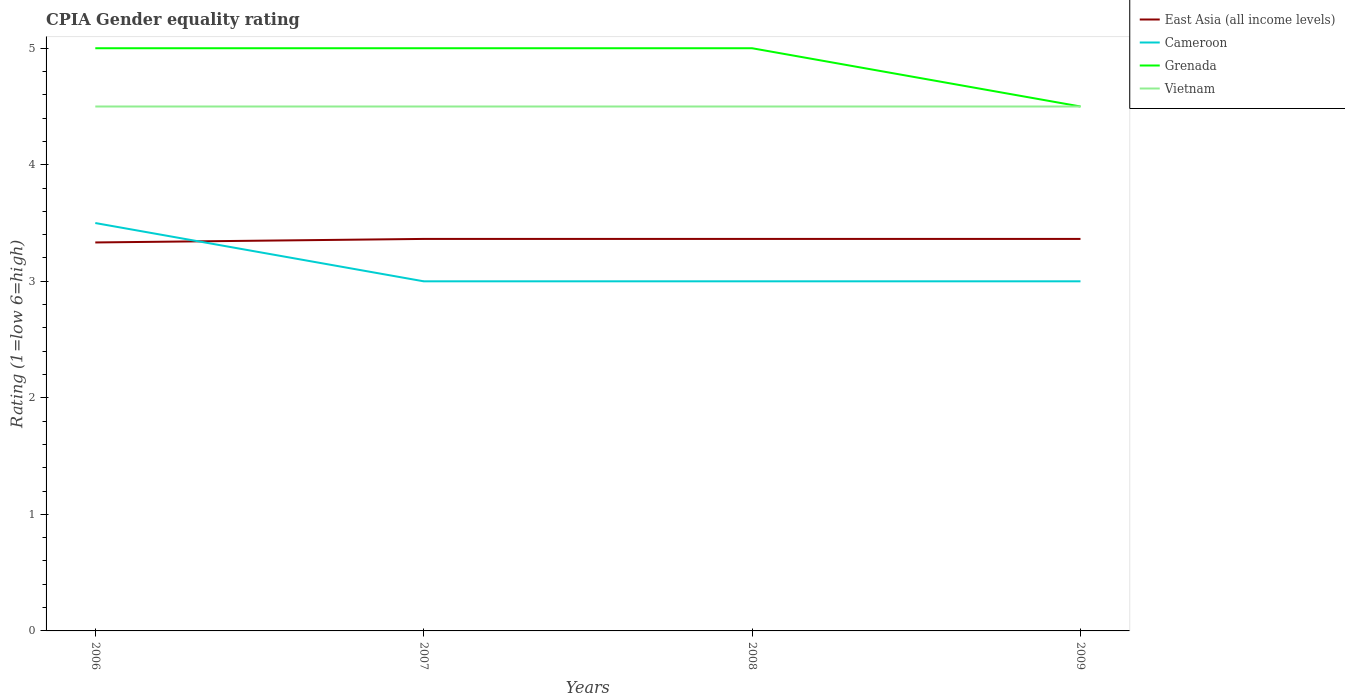In which year was the CPIA rating in Grenada maximum?
Provide a succinct answer. 2009. What is the total CPIA rating in Cameroon in the graph?
Keep it short and to the point. 0.5. What is the difference between the highest and the second highest CPIA rating in Cameroon?
Your answer should be compact. 0.5. How many lines are there?
Provide a short and direct response. 4. How many years are there in the graph?
Offer a very short reply. 4. How many legend labels are there?
Your answer should be compact. 4. What is the title of the graph?
Give a very brief answer. CPIA Gender equality rating. Does "East Asia (developing only)" appear as one of the legend labels in the graph?
Provide a succinct answer. No. What is the label or title of the X-axis?
Ensure brevity in your answer.  Years. What is the Rating (1=low 6=high) in East Asia (all income levels) in 2006?
Provide a succinct answer. 3.33. What is the Rating (1=low 6=high) in East Asia (all income levels) in 2007?
Keep it short and to the point. 3.36. What is the Rating (1=low 6=high) of Grenada in 2007?
Your response must be concise. 5. What is the Rating (1=low 6=high) in East Asia (all income levels) in 2008?
Make the answer very short. 3.36. What is the Rating (1=low 6=high) in Grenada in 2008?
Offer a terse response. 5. What is the Rating (1=low 6=high) in Vietnam in 2008?
Provide a succinct answer. 4.5. What is the Rating (1=low 6=high) in East Asia (all income levels) in 2009?
Your answer should be very brief. 3.36. What is the Rating (1=low 6=high) in Grenada in 2009?
Keep it short and to the point. 4.5. What is the Rating (1=low 6=high) of Vietnam in 2009?
Provide a succinct answer. 4.5. Across all years, what is the maximum Rating (1=low 6=high) of East Asia (all income levels)?
Your response must be concise. 3.36. Across all years, what is the maximum Rating (1=low 6=high) in Cameroon?
Give a very brief answer. 3.5. Across all years, what is the maximum Rating (1=low 6=high) of Grenada?
Your answer should be very brief. 5. Across all years, what is the maximum Rating (1=low 6=high) of Vietnam?
Your answer should be compact. 4.5. Across all years, what is the minimum Rating (1=low 6=high) of East Asia (all income levels)?
Make the answer very short. 3.33. What is the total Rating (1=low 6=high) in East Asia (all income levels) in the graph?
Your answer should be very brief. 13.42. What is the total Rating (1=low 6=high) of Vietnam in the graph?
Give a very brief answer. 18. What is the difference between the Rating (1=low 6=high) of East Asia (all income levels) in 2006 and that in 2007?
Your response must be concise. -0.03. What is the difference between the Rating (1=low 6=high) in Cameroon in 2006 and that in 2007?
Offer a terse response. 0.5. What is the difference between the Rating (1=low 6=high) in Grenada in 2006 and that in 2007?
Give a very brief answer. 0. What is the difference between the Rating (1=low 6=high) in East Asia (all income levels) in 2006 and that in 2008?
Your response must be concise. -0.03. What is the difference between the Rating (1=low 6=high) in Cameroon in 2006 and that in 2008?
Provide a succinct answer. 0.5. What is the difference between the Rating (1=low 6=high) of East Asia (all income levels) in 2006 and that in 2009?
Ensure brevity in your answer.  -0.03. What is the difference between the Rating (1=low 6=high) of Cameroon in 2006 and that in 2009?
Your answer should be compact. 0.5. What is the difference between the Rating (1=low 6=high) of Vietnam in 2006 and that in 2009?
Your response must be concise. 0. What is the difference between the Rating (1=low 6=high) of East Asia (all income levels) in 2007 and that in 2008?
Provide a short and direct response. 0. What is the difference between the Rating (1=low 6=high) in Vietnam in 2007 and that in 2008?
Offer a very short reply. 0. What is the difference between the Rating (1=low 6=high) in East Asia (all income levels) in 2007 and that in 2009?
Ensure brevity in your answer.  0. What is the difference between the Rating (1=low 6=high) in Grenada in 2007 and that in 2009?
Ensure brevity in your answer.  0.5. What is the difference between the Rating (1=low 6=high) of Vietnam in 2007 and that in 2009?
Provide a short and direct response. 0. What is the difference between the Rating (1=low 6=high) of Cameroon in 2008 and that in 2009?
Your response must be concise. 0. What is the difference between the Rating (1=low 6=high) in Grenada in 2008 and that in 2009?
Ensure brevity in your answer.  0.5. What is the difference between the Rating (1=low 6=high) of East Asia (all income levels) in 2006 and the Rating (1=low 6=high) of Grenada in 2007?
Keep it short and to the point. -1.67. What is the difference between the Rating (1=low 6=high) of East Asia (all income levels) in 2006 and the Rating (1=low 6=high) of Vietnam in 2007?
Ensure brevity in your answer.  -1.17. What is the difference between the Rating (1=low 6=high) in East Asia (all income levels) in 2006 and the Rating (1=low 6=high) in Cameroon in 2008?
Your answer should be compact. 0.33. What is the difference between the Rating (1=low 6=high) of East Asia (all income levels) in 2006 and the Rating (1=low 6=high) of Grenada in 2008?
Your answer should be very brief. -1.67. What is the difference between the Rating (1=low 6=high) of East Asia (all income levels) in 2006 and the Rating (1=low 6=high) of Vietnam in 2008?
Offer a terse response. -1.17. What is the difference between the Rating (1=low 6=high) of Cameroon in 2006 and the Rating (1=low 6=high) of Vietnam in 2008?
Offer a very short reply. -1. What is the difference between the Rating (1=low 6=high) in East Asia (all income levels) in 2006 and the Rating (1=low 6=high) in Cameroon in 2009?
Keep it short and to the point. 0.33. What is the difference between the Rating (1=low 6=high) of East Asia (all income levels) in 2006 and the Rating (1=low 6=high) of Grenada in 2009?
Provide a succinct answer. -1.17. What is the difference between the Rating (1=low 6=high) in East Asia (all income levels) in 2006 and the Rating (1=low 6=high) in Vietnam in 2009?
Offer a terse response. -1.17. What is the difference between the Rating (1=low 6=high) in East Asia (all income levels) in 2007 and the Rating (1=low 6=high) in Cameroon in 2008?
Your answer should be very brief. 0.36. What is the difference between the Rating (1=low 6=high) of East Asia (all income levels) in 2007 and the Rating (1=low 6=high) of Grenada in 2008?
Provide a succinct answer. -1.64. What is the difference between the Rating (1=low 6=high) in East Asia (all income levels) in 2007 and the Rating (1=low 6=high) in Vietnam in 2008?
Your answer should be compact. -1.14. What is the difference between the Rating (1=low 6=high) in Cameroon in 2007 and the Rating (1=low 6=high) in Vietnam in 2008?
Ensure brevity in your answer.  -1.5. What is the difference between the Rating (1=low 6=high) in East Asia (all income levels) in 2007 and the Rating (1=low 6=high) in Cameroon in 2009?
Offer a terse response. 0.36. What is the difference between the Rating (1=low 6=high) in East Asia (all income levels) in 2007 and the Rating (1=low 6=high) in Grenada in 2009?
Offer a very short reply. -1.14. What is the difference between the Rating (1=low 6=high) of East Asia (all income levels) in 2007 and the Rating (1=low 6=high) of Vietnam in 2009?
Make the answer very short. -1.14. What is the difference between the Rating (1=low 6=high) in Grenada in 2007 and the Rating (1=low 6=high) in Vietnam in 2009?
Your answer should be very brief. 0.5. What is the difference between the Rating (1=low 6=high) in East Asia (all income levels) in 2008 and the Rating (1=low 6=high) in Cameroon in 2009?
Ensure brevity in your answer.  0.36. What is the difference between the Rating (1=low 6=high) of East Asia (all income levels) in 2008 and the Rating (1=low 6=high) of Grenada in 2009?
Offer a terse response. -1.14. What is the difference between the Rating (1=low 6=high) in East Asia (all income levels) in 2008 and the Rating (1=low 6=high) in Vietnam in 2009?
Ensure brevity in your answer.  -1.14. What is the difference between the Rating (1=low 6=high) of Cameroon in 2008 and the Rating (1=low 6=high) of Grenada in 2009?
Offer a very short reply. -1.5. What is the difference between the Rating (1=low 6=high) in Cameroon in 2008 and the Rating (1=low 6=high) in Vietnam in 2009?
Offer a terse response. -1.5. What is the average Rating (1=low 6=high) in East Asia (all income levels) per year?
Your answer should be compact. 3.36. What is the average Rating (1=low 6=high) in Cameroon per year?
Offer a very short reply. 3.12. What is the average Rating (1=low 6=high) of Grenada per year?
Keep it short and to the point. 4.88. What is the average Rating (1=low 6=high) of Vietnam per year?
Offer a very short reply. 4.5. In the year 2006, what is the difference between the Rating (1=low 6=high) of East Asia (all income levels) and Rating (1=low 6=high) of Grenada?
Your answer should be very brief. -1.67. In the year 2006, what is the difference between the Rating (1=low 6=high) of East Asia (all income levels) and Rating (1=low 6=high) of Vietnam?
Your answer should be very brief. -1.17. In the year 2006, what is the difference between the Rating (1=low 6=high) of Grenada and Rating (1=low 6=high) of Vietnam?
Give a very brief answer. 0.5. In the year 2007, what is the difference between the Rating (1=low 6=high) in East Asia (all income levels) and Rating (1=low 6=high) in Cameroon?
Give a very brief answer. 0.36. In the year 2007, what is the difference between the Rating (1=low 6=high) of East Asia (all income levels) and Rating (1=low 6=high) of Grenada?
Offer a very short reply. -1.64. In the year 2007, what is the difference between the Rating (1=low 6=high) of East Asia (all income levels) and Rating (1=low 6=high) of Vietnam?
Provide a short and direct response. -1.14. In the year 2007, what is the difference between the Rating (1=low 6=high) of Cameroon and Rating (1=low 6=high) of Vietnam?
Provide a succinct answer. -1.5. In the year 2007, what is the difference between the Rating (1=low 6=high) in Grenada and Rating (1=low 6=high) in Vietnam?
Offer a terse response. 0.5. In the year 2008, what is the difference between the Rating (1=low 6=high) of East Asia (all income levels) and Rating (1=low 6=high) of Cameroon?
Make the answer very short. 0.36. In the year 2008, what is the difference between the Rating (1=low 6=high) of East Asia (all income levels) and Rating (1=low 6=high) of Grenada?
Keep it short and to the point. -1.64. In the year 2008, what is the difference between the Rating (1=low 6=high) of East Asia (all income levels) and Rating (1=low 6=high) of Vietnam?
Make the answer very short. -1.14. In the year 2008, what is the difference between the Rating (1=low 6=high) in Cameroon and Rating (1=low 6=high) in Grenada?
Give a very brief answer. -2. In the year 2008, what is the difference between the Rating (1=low 6=high) of Cameroon and Rating (1=low 6=high) of Vietnam?
Provide a succinct answer. -1.5. In the year 2009, what is the difference between the Rating (1=low 6=high) in East Asia (all income levels) and Rating (1=low 6=high) in Cameroon?
Give a very brief answer. 0.36. In the year 2009, what is the difference between the Rating (1=low 6=high) in East Asia (all income levels) and Rating (1=low 6=high) in Grenada?
Your answer should be very brief. -1.14. In the year 2009, what is the difference between the Rating (1=low 6=high) in East Asia (all income levels) and Rating (1=low 6=high) in Vietnam?
Make the answer very short. -1.14. In the year 2009, what is the difference between the Rating (1=low 6=high) of Cameroon and Rating (1=low 6=high) of Grenada?
Your answer should be very brief. -1.5. In the year 2009, what is the difference between the Rating (1=low 6=high) in Cameroon and Rating (1=low 6=high) in Vietnam?
Make the answer very short. -1.5. In the year 2009, what is the difference between the Rating (1=low 6=high) of Grenada and Rating (1=low 6=high) of Vietnam?
Make the answer very short. 0. What is the ratio of the Rating (1=low 6=high) in East Asia (all income levels) in 2006 to that in 2007?
Ensure brevity in your answer.  0.99. What is the ratio of the Rating (1=low 6=high) in Cameroon in 2006 to that in 2007?
Provide a succinct answer. 1.17. What is the ratio of the Rating (1=low 6=high) of Grenada in 2006 to that in 2007?
Provide a succinct answer. 1. What is the ratio of the Rating (1=low 6=high) in Vietnam in 2006 to that in 2007?
Your answer should be very brief. 1. What is the ratio of the Rating (1=low 6=high) in East Asia (all income levels) in 2006 to that in 2008?
Provide a succinct answer. 0.99. What is the ratio of the Rating (1=low 6=high) of Grenada in 2006 to that in 2009?
Your answer should be very brief. 1.11. What is the ratio of the Rating (1=low 6=high) of Vietnam in 2007 to that in 2008?
Give a very brief answer. 1. What is the ratio of the Rating (1=low 6=high) of East Asia (all income levels) in 2007 to that in 2009?
Offer a very short reply. 1. What is the ratio of the Rating (1=low 6=high) in Grenada in 2007 to that in 2009?
Provide a succinct answer. 1.11. What is the ratio of the Rating (1=low 6=high) of Cameroon in 2008 to that in 2009?
Your answer should be very brief. 1. What is the difference between the highest and the second highest Rating (1=low 6=high) in East Asia (all income levels)?
Provide a short and direct response. 0. What is the difference between the highest and the second highest Rating (1=low 6=high) of Cameroon?
Ensure brevity in your answer.  0.5. What is the difference between the highest and the second highest Rating (1=low 6=high) in Vietnam?
Offer a terse response. 0. What is the difference between the highest and the lowest Rating (1=low 6=high) in East Asia (all income levels)?
Your answer should be compact. 0.03. What is the difference between the highest and the lowest Rating (1=low 6=high) in Cameroon?
Keep it short and to the point. 0.5. 